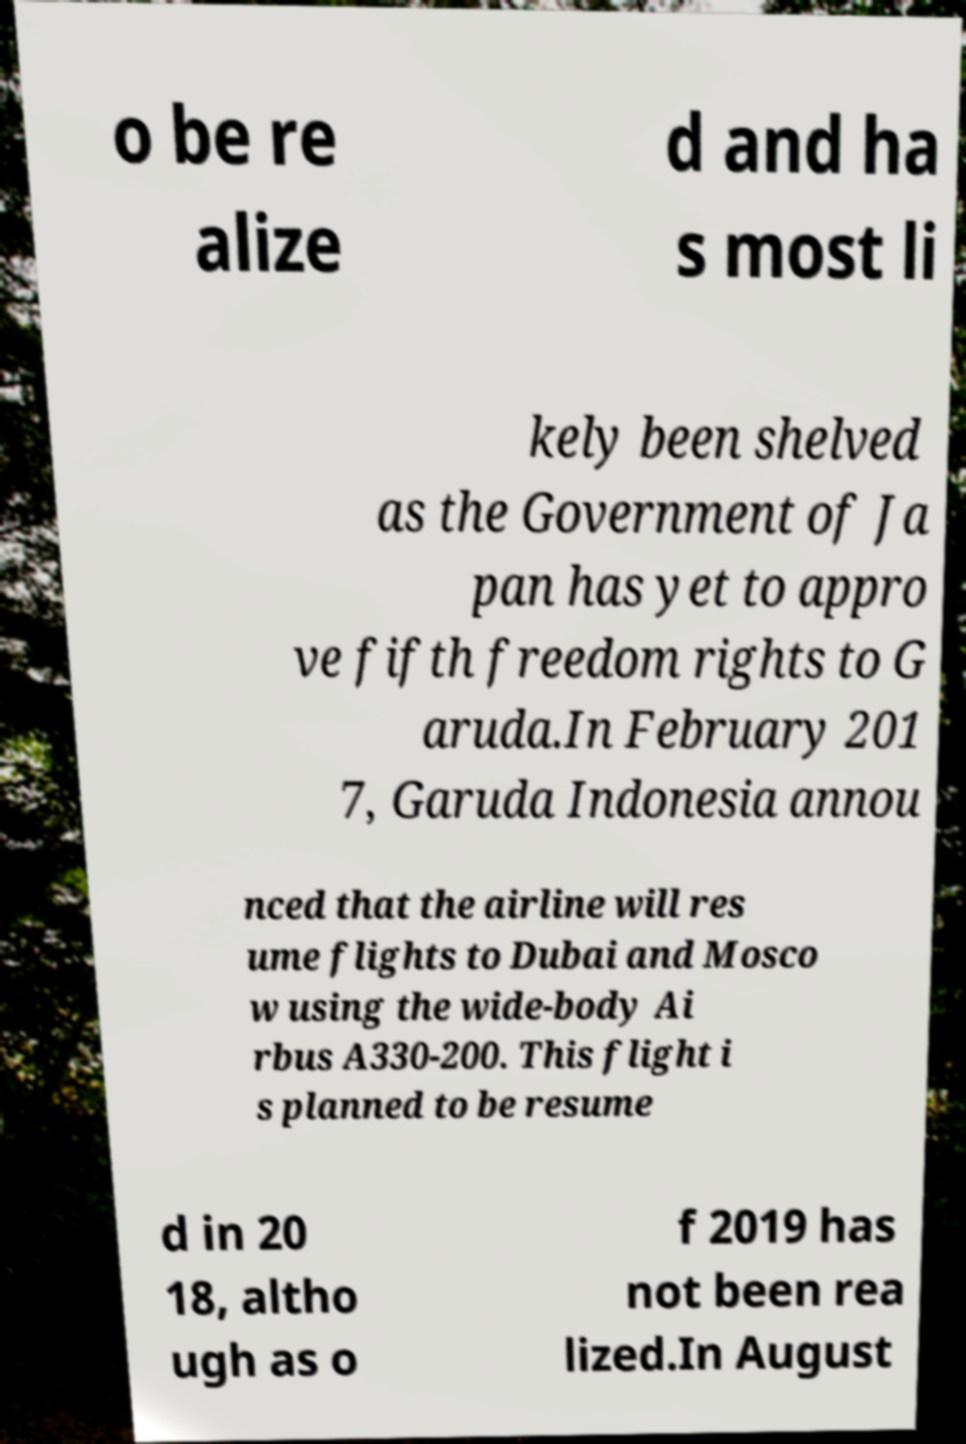Please read and relay the text visible in this image. What does it say? o be re alize d and ha s most li kely been shelved as the Government of Ja pan has yet to appro ve fifth freedom rights to G aruda.In February 201 7, Garuda Indonesia annou nced that the airline will res ume flights to Dubai and Mosco w using the wide-body Ai rbus A330-200. This flight i s planned to be resume d in 20 18, altho ugh as o f 2019 has not been rea lized.In August 